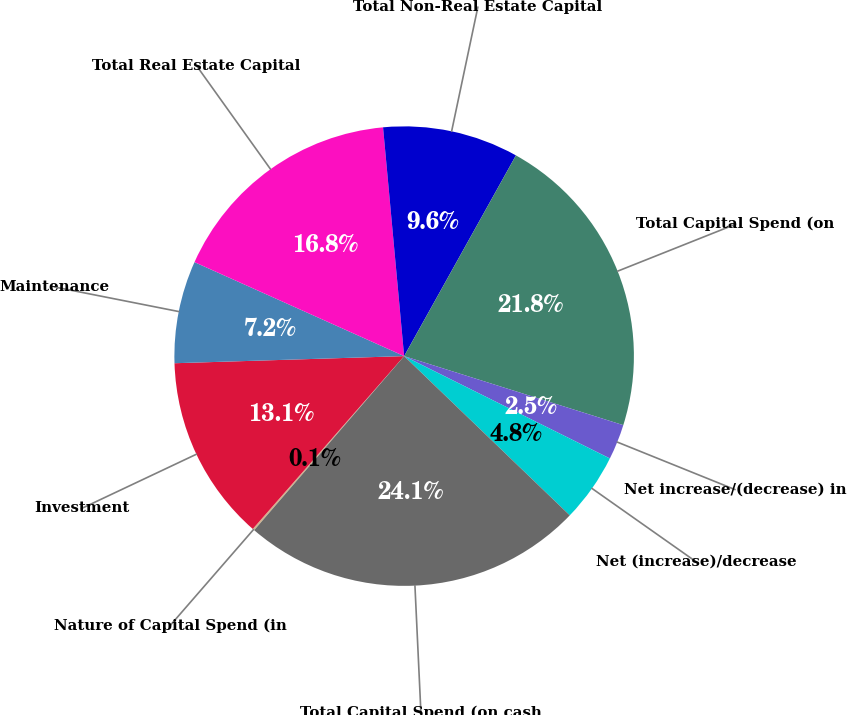<chart> <loc_0><loc_0><loc_500><loc_500><pie_chart><fcel>Nature of Capital Spend (in<fcel>Investment<fcel>Maintenance<fcel>Total Real Estate Capital<fcel>Total Non-Real Estate Capital<fcel>Total Capital Spend (on<fcel>Net increase/(decrease) in<fcel>Net (increase)/decrease<fcel>Total Capital Spend (on cash<nl><fcel>0.13%<fcel>13.06%<fcel>7.2%<fcel>16.83%<fcel>9.55%<fcel>21.77%<fcel>2.49%<fcel>4.84%<fcel>24.13%<nl></chart> 